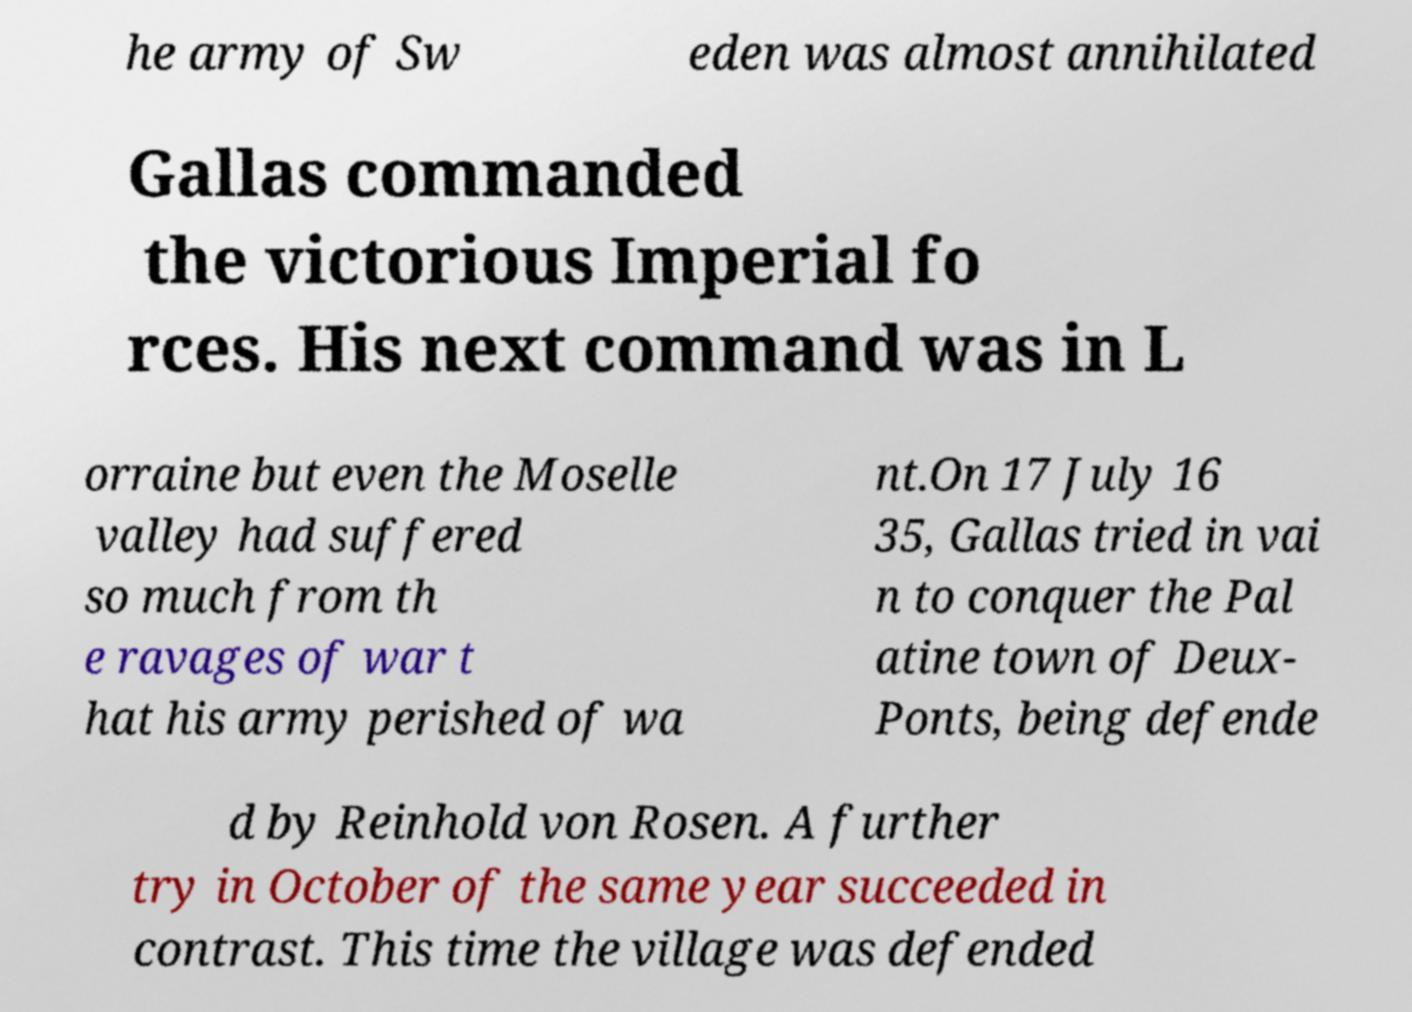Can you accurately transcribe the text from the provided image for me? he army of Sw eden was almost annihilated Gallas commanded the victorious Imperial fo rces. His next command was in L orraine but even the Moselle valley had suffered so much from th e ravages of war t hat his army perished of wa nt.On 17 July 16 35, Gallas tried in vai n to conquer the Pal atine town of Deux- Ponts, being defende d by Reinhold von Rosen. A further try in October of the same year succeeded in contrast. This time the village was defended 